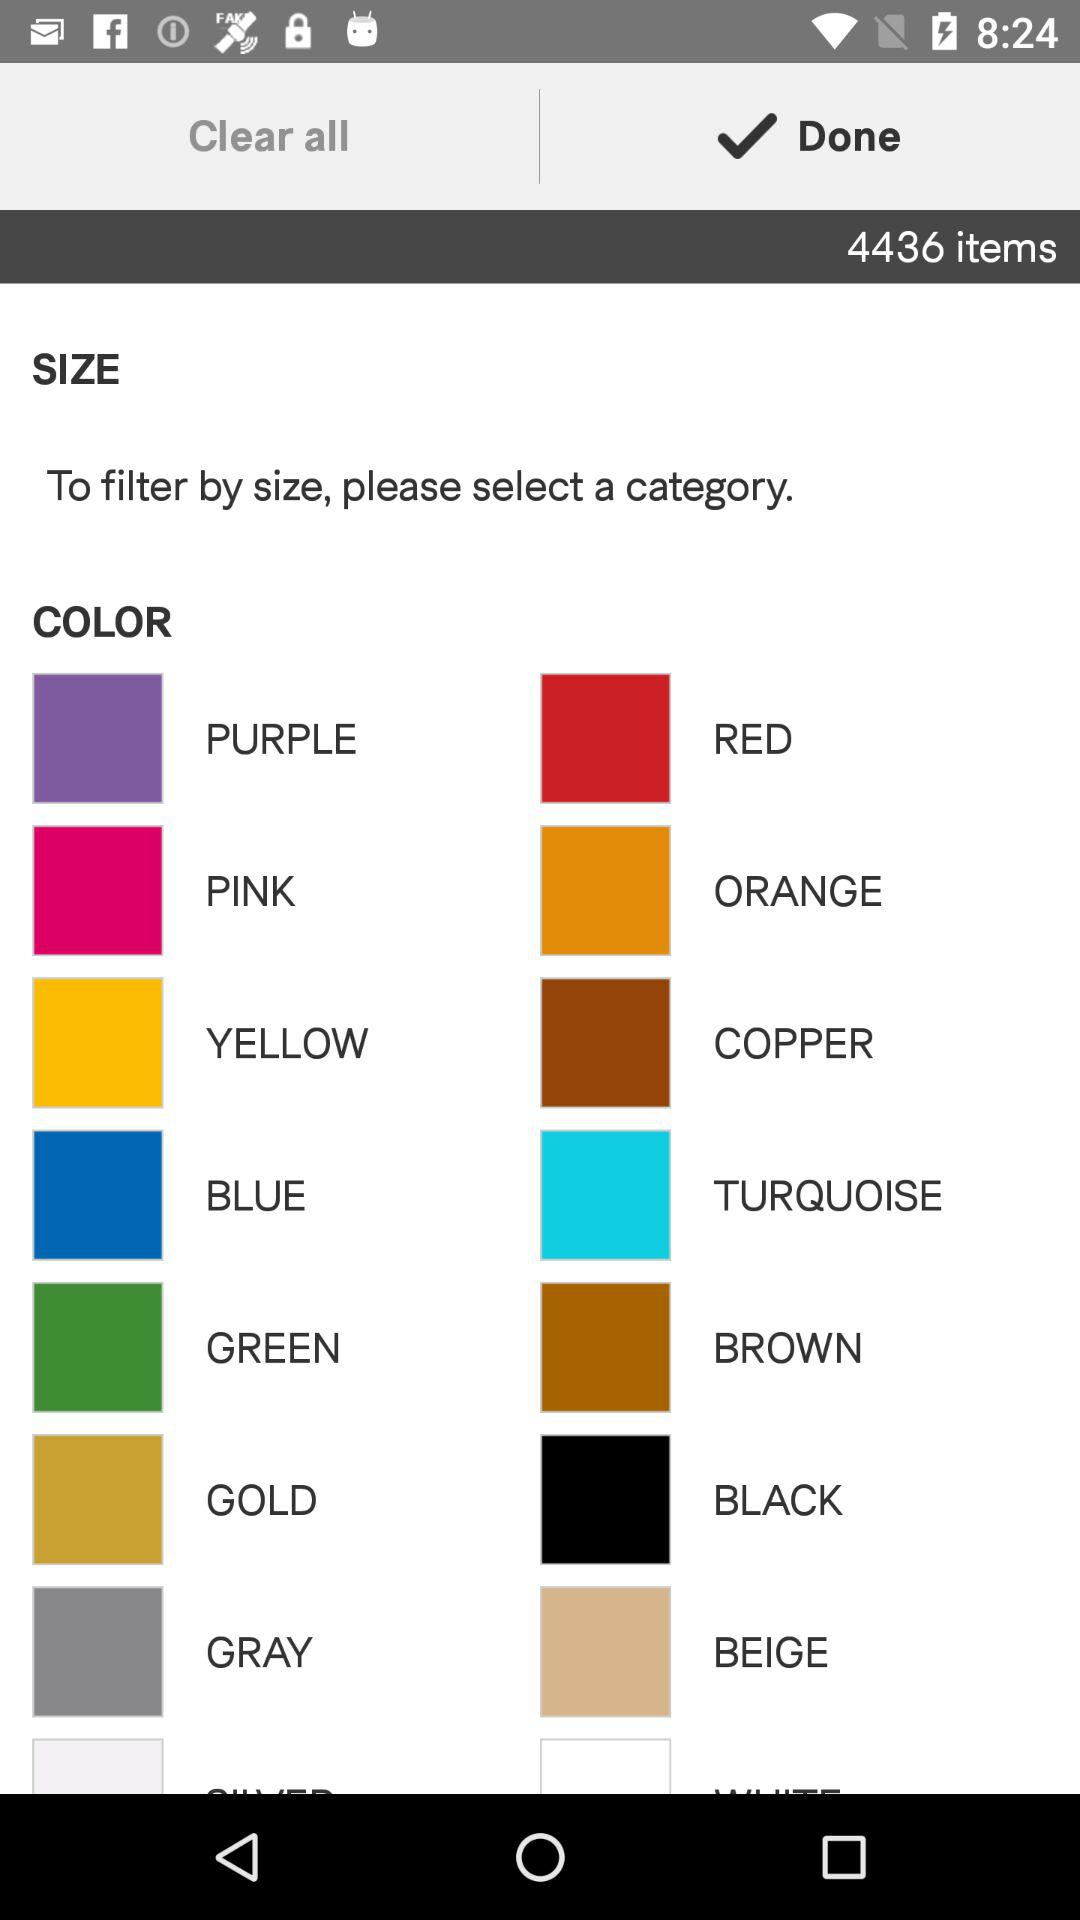Which option is checked? The checked option is "Done". 